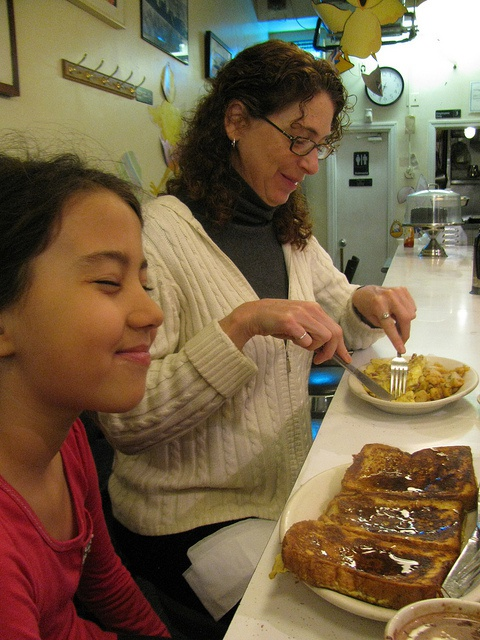Describe the objects in this image and their specific colors. I can see people in olive, black, tan, and gray tones, people in olive, maroon, black, and brown tones, dining table in olive, maroon, and tan tones, sandwich in olive, maroon, and black tones, and bowl in olive and tan tones in this image. 